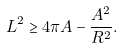<formula> <loc_0><loc_0><loc_500><loc_500>L ^ { 2 } \geq 4 \pi A - { \frac { A ^ { 2 } } { R ^ { 2 } } } .</formula> 